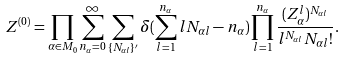<formula> <loc_0><loc_0><loc_500><loc_500>Z ^ { ( 0 ) } = \prod _ { \alpha \in M _ { 0 } } \sum _ { n _ { \alpha } = 0 } ^ { \infty } \sum _ { \{ N _ { \alpha l } \} ^ { \prime } } \delta ( \sum _ { l = 1 } ^ { n _ { \alpha } } l N _ { \alpha l } - n _ { \alpha } ) \prod _ { l = 1 } ^ { n _ { \alpha } } \frac { ( Z _ { \alpha } ^ { l } ) ^ { N _ { \alpha l } } } { l ^ { N _ { \alpha l } } N _ { \alpha l } ! } .</formula> 